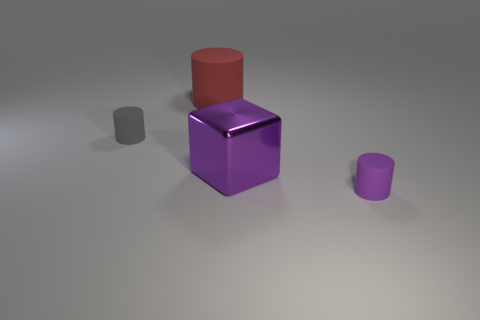How big is the cylinder that is on the right side of the red matte cylinder?
Provide a succinct answer. Small. Is the size of the shiny block the same as the cylinder that is in front of the large purple metallic cube?
Provide a succinct answer. No. The tiny rubber cylinder in front of the small thing on the left side of the tiny purple object is what color?
Offer a terse response. Purple. How many other objects are there of the same color as the large metallic block?
Provide a short and direct response. 1. The gray thing is what size?
Give a very brief answer. Small. Is the number of big purple shiny blocks that are in front of the metal cube greater than the number of rubber cylinders that are left of the small gray cylinder?
Provide a short and direct response. No. There is a tiny matte object behind the tiny purple thing; what number of large red objects are left of it?
Your response must be concise. 0. There is a tiny matte object that is on the right side of the purple shiny block; does it have the same shape as the big purple thing?
Keep it short and to the point. No. What is the material of the gray thing that is the same shape as the big red thing?
Offer a very short reply. Rubber. How many shiny things are the same size as the purple rubber thing?
Provide a short and direct response. 0. 